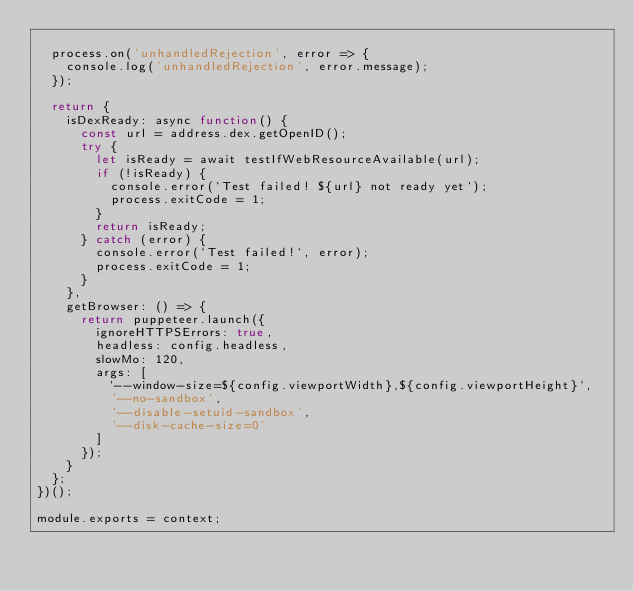<code> <loc_0><loc_0><loc_500><loc_500><_JavaScript_>
  process.on('unhandledRejection', error => {
    console.log('unhandledRejection', error.message);
  });

  return {
    isDexReady: async function() {
      const url = address.dex.getOpenID();
      try {
        let isReady = await testIfWebResourceAvailable(url);
        if (!isReady) {
          console.error(`Test failed! ${url} not ready yet`);
          process.exitCode = 1;
        }
        return isReady;
      } catch (error) {
        console.error(`Test failed!`, error);
        process.exitCode = 1;
      }
    },
    getBrowser: () => {
      return puppeteer.launch({
        ignoreHTTPSErrors: true,
        headless: config.headless,
        slowMo: 120,
        args: [
          `--window-size=${config.viewportWidth},${config.viewportHeight}`,
          '--no-sandbox',
          '--disable-setuid-sandbox',
          '--disk-cache-size=0'
        ]
      });
    }
  };
})();

module.exports = context;
</code> 